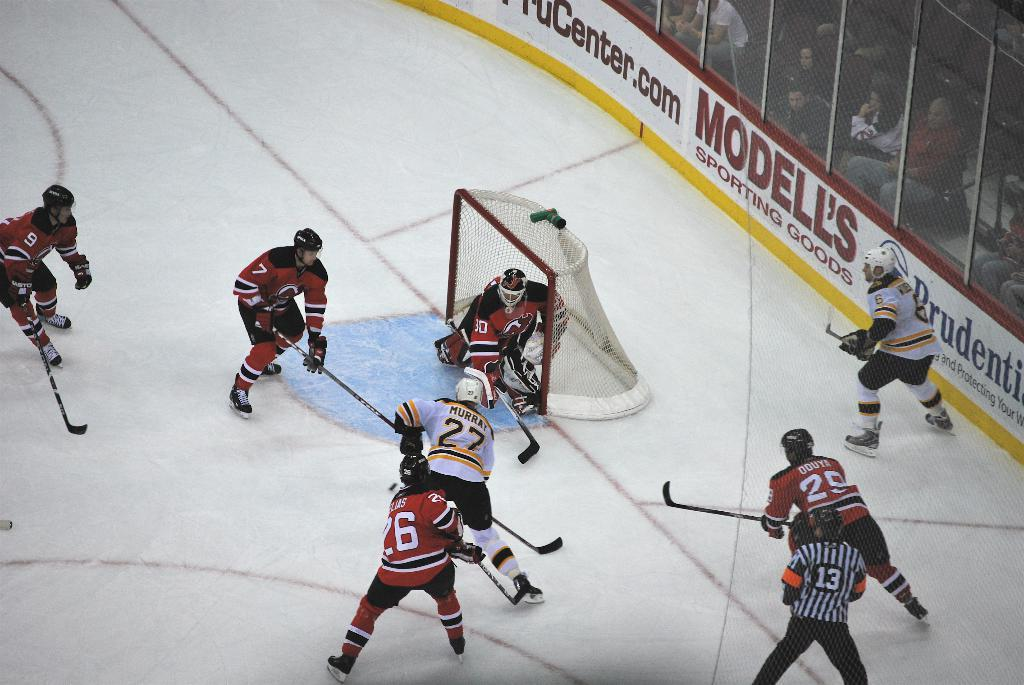<image>
Share a concise interpretation of the image provided. a few hockey players with one wearing the number 27 that has the puck 